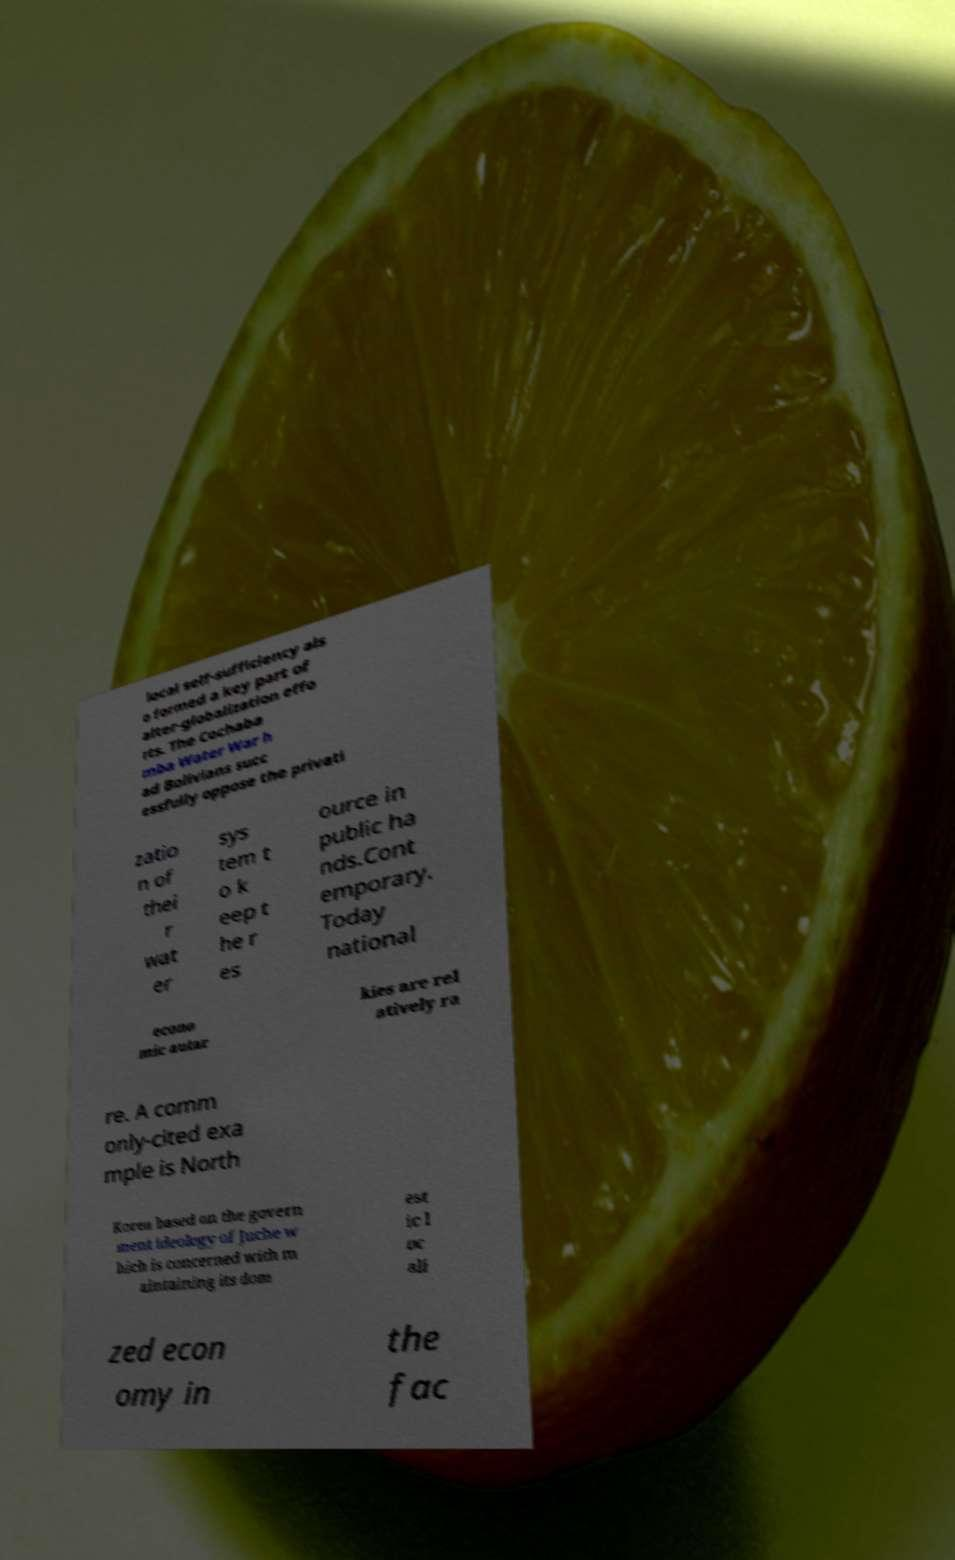There's text embedded in this image that I need extracted. Can you transcribe it verbatim? local self-sufficiency als o formed a key part of alter-globalization effo rts. The Cochaba mba Water War h ad Bolivians succ essfully oppose the privati zatio n of thei r wat er sys tem t o k eep t he r es ource in public ha nds.Cont emporary. Today national econo mic autar kies are rel atively ra re. A comm only-cited exa mple is North Korea based on the govern ment ideology of Juche w hich is concerned with m aintaining its dom est ic l oc ali zed econ omy in the fac 